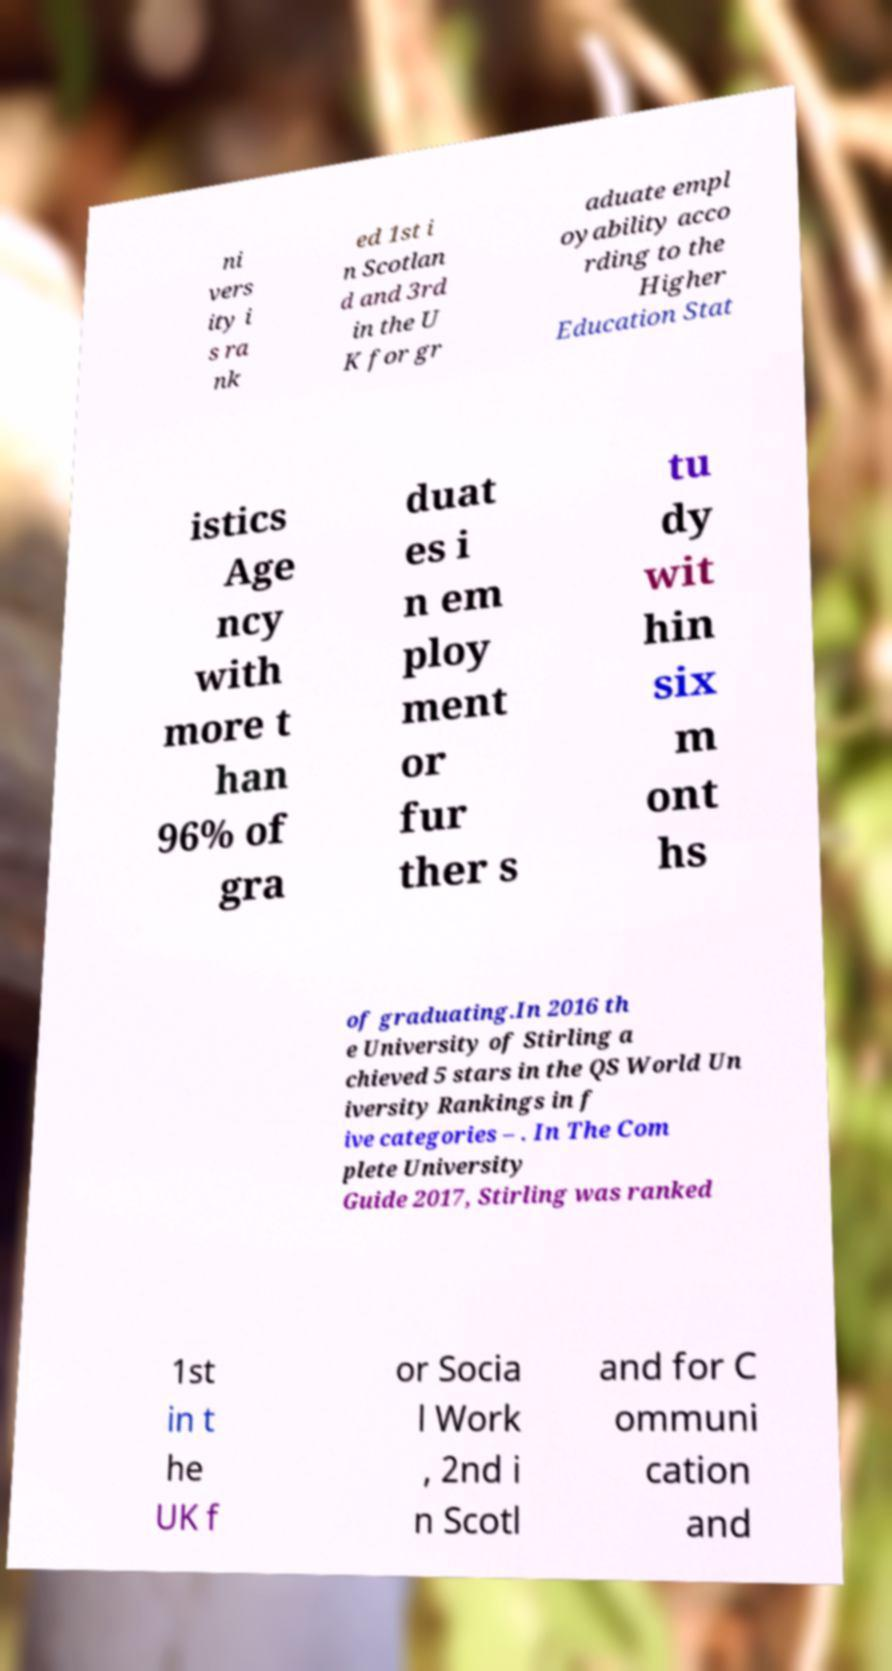Could you assist in decoding the text presented in this image and type it out clearly? ni vers ity i s ra nk ed 1st i n Scotlan d and 3rd in the U K for gr aduate empl oyability acco rding to the Higher Education Stat istics Age ncy with more t han 96% of gra duat es i n em ploy ment or fur ther s tu dy wit hin six m ont hs of graduating.In 2016 th e University of Stirling a chieved 5 stars in the QS World Un iversity Rankings in f ive categories – . In The Com plete University Guide 2017, Stirling was ranked 1st in t he UK f or Socia l Work , 2nd i n Scotl and for C ommuni cation and 